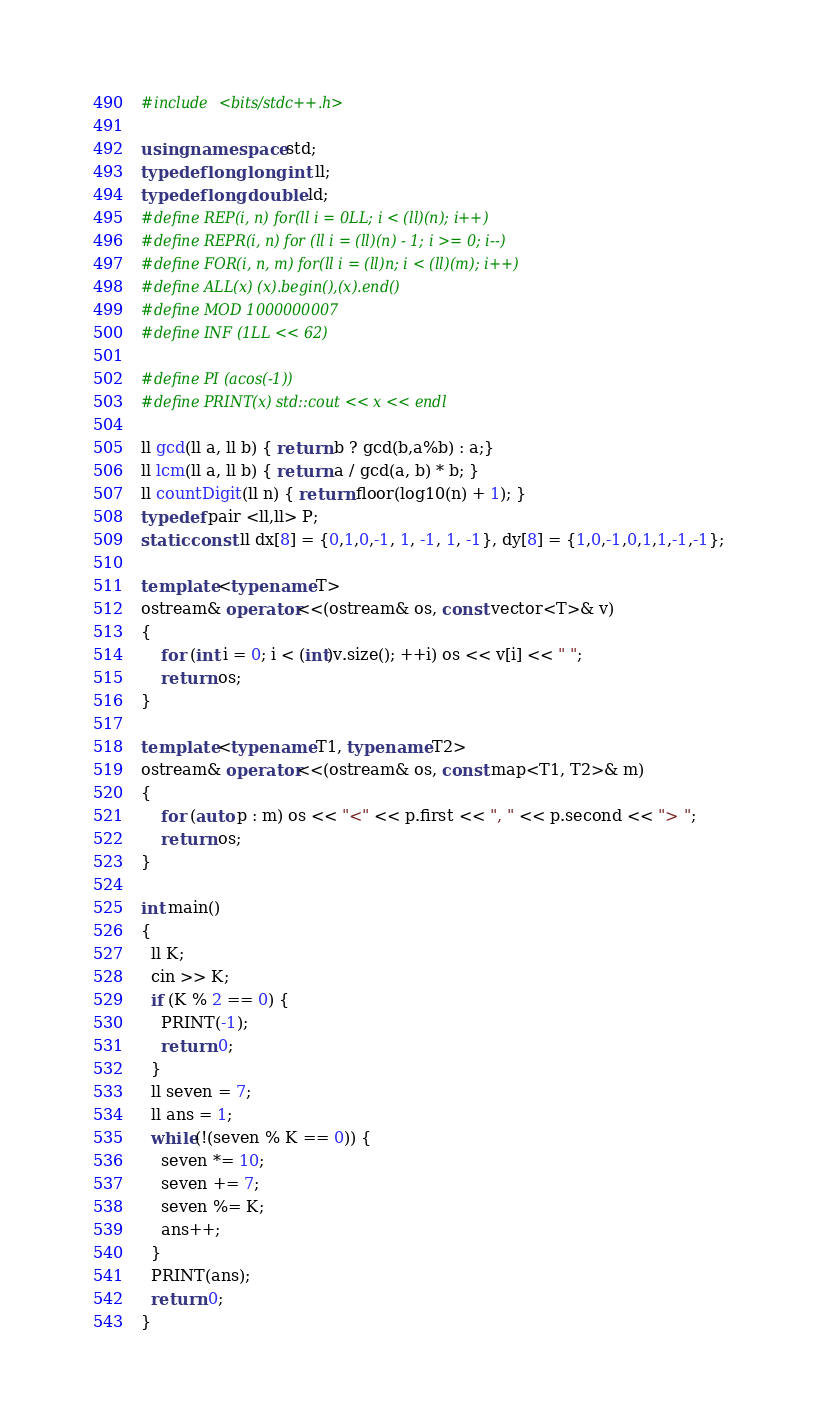<code> <loc_0><loc_0><loc_500><loc_500><_C++_>#include <bits/stdc++.h>

using namespace std;
typedef long long int ll;
typedef long double ld;
#define REP(i, n) for(ll i = 0LL; i < (ll)(n); i++)
#define REPR(i, n) for (ll i = (ll)(n) - 1; i >= 0; i--)
#define FOR(i, n, m) for(ll i = (ll)n; i < (ll)(m); i++)
#define ALL(x) (x).begin(),(x).end()
#define MOD 1000000007
#define INF (1LL << 62)

#define PI (acos(-1))
#define PRINT(x) std::cout << x << endl
 
ll gcd(ll a, ll b) { return b ? gcd(b,a%b) : a;}
ll lcm(ll a, ll b) { return a / gcd(a, b) * b; }
ll countDigit(ll n) { return floor(log10(n) + 1); } 
typedef pair <ll,ll> P;
static const ll dx[8] = {0,1,0,-1, 1, -1, 1, -1}, dy[8] = {1,0,-1,0,1,1,-1,-1};

template <typename T> 
ostream& operator<<(ostream& os, const vector<T>& v) 
{ 
    for (int i = 0; i < (int)v.size(); ++i) os << v[i] << " ";  
    return os; 
}

template <typename T1, typename T2> 
ostream& operator<<(ostream& os, const map<T1, T2>& m) 
{ 
    for (auto p : m) os << "<" << p.first << ", " << p.second << "> "; 
    return os; 
}

int main()
{ 
  ll K;
  cin >> K;
  if (K % 2 == 0) {
    PRINT(-1);
    return 0;
  }
  ll seven = 7;
  ll ans = 1;
  while(!(seven % K == 0)) {
    seven *= 10;
    seven += 7;
    seven %= K;
    ans++;
  }
  PRINT(ans);
  return 0;
} 
</code> 